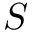<formula> <loc_0><loc_0><loc_500><loc_500>S</formula> 